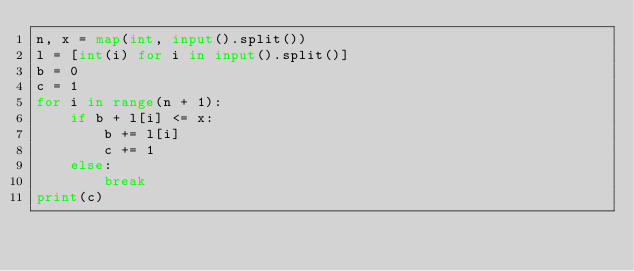<code> <loc_0><loc_0><loc_500><loc_500><_Python_>n, x = map(int, input().split())
l = [int(i) for i in input().split()]
b = 0
c = 1
for i in range(n + 1):
    if b + l[i] <= x:
        b += l[i]
        c += 1
    else:
        break
print(c)</code> 